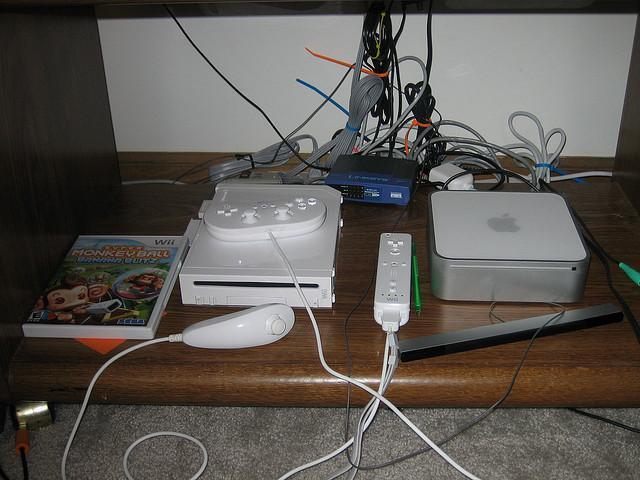How many remotes are there?
Give a very brief answer. 3. How many books can be seen?
Give a very brief answer. 1. How many fingers is the man holding up?
Give a very brief answer. 0. 